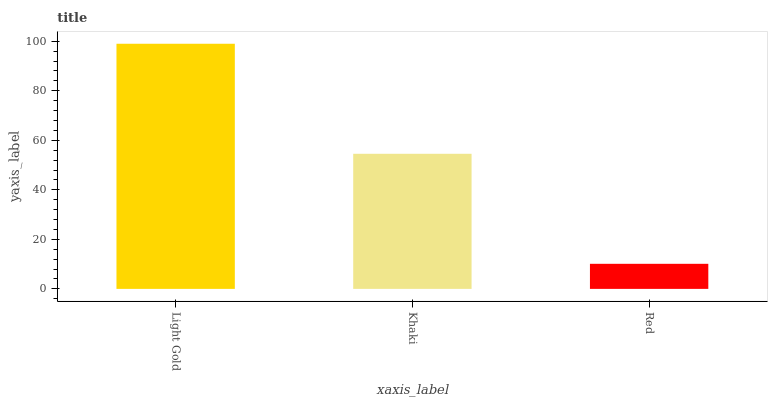Is Red the minimum?
Answer yes or no. Yes. Is Light Gold the maximum?
Answer yes or no. Yes. Is Khaki the minimum?
Answer yes or no. No. Is Khaki the maximum?
Answer yes or no. No. Is Light Gold greater than Khaki?
Answer yes or no. Yes. Is Khaki less than Light Gold?
Answer yes or no. Yes. Is Khaki greater than Light Gold?
Answer yes or no. No. Is Light Gold less than Khaki?
Answer yes or no. No. Is Khaki the high median?
Answer yes or no. Yes. Is Khaki the low median?
Answer yes or no. Yes. Is Red the high median?
Answer yes or no. No. Is Red the low median?
Answer yes or no. No. 